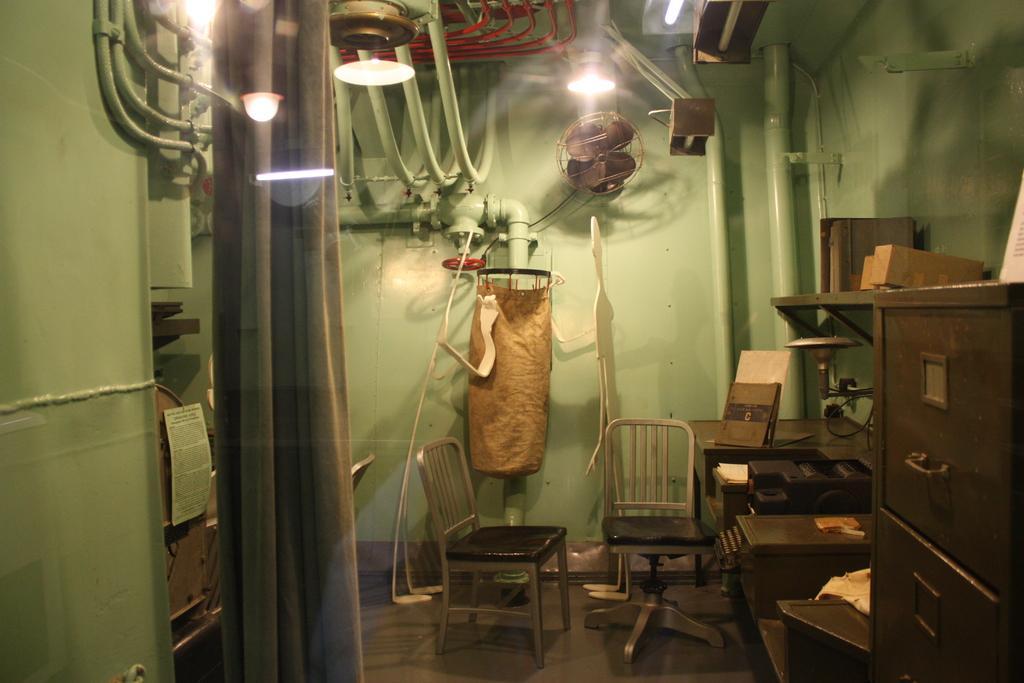In one or two sentences, can you explain what this image depicts? Here we have chairs,fan,light,iron box. 